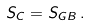<formula> <loc_0><loc_0><loc_500><loc_500>S _ { C } = S _ { G B } \, .</formula> 